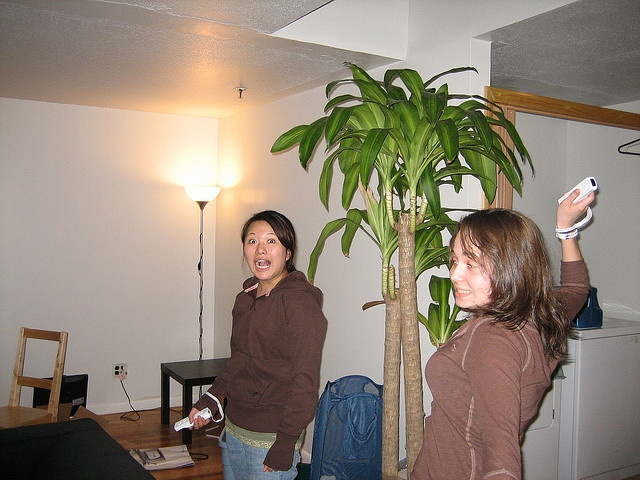Describe the objects in this image and their specific colors. I can see potted plant in gray, darkgreen, tan, and darkgray tones, people in gray, brown, black, and maroon tones, people in gray, maroon, and black tones, couch in gray, black, and maroon tones, and dining table in gray, black, and maroon tones in this image. 